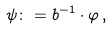Convert formula to latex. <formula><loc_0><loc_0><loc_500><loc_500>\psi \colon = b ^ { - 1 } \cdot \varphi \, ,</formula> 